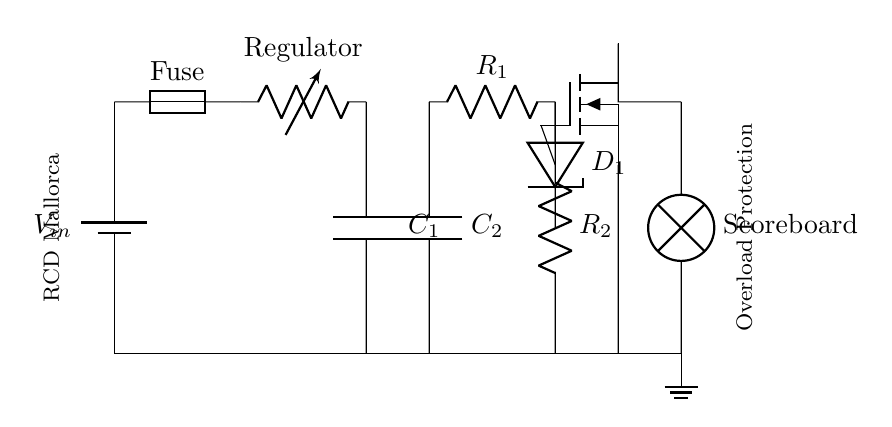What is the input component in this circuit? The input component is the battery, which supplies the voltage to the circuit. In the diagram, it is labeled as V_in.
Answer: battery What does the fuse protect in this circuit? The fuse protects the circuit from overload conditions by breaking the circuit if the current exceeds a certain threshold. This prevents damage to components like the scoreboard.
Answer: overload How many capacitors are used in the circuit? The circuit has two capacitors, labeled C1 and C2, which are used for filtering and stabilizing the voltage.
Answer: two What is the purpose of the MOSFET in this circuit? The MOSFET acts as a switch that controls the power to the scoreboard based on the signals it receives, thereby protecting against overloads.
Answer: switch What is the output load in this circuit? The output load is the scoreboard, which is represented as a lamp in the circuit. It receives power from the output side of the MOSFET.
Answer: scoreboard What role does the Zener diode play in this circuit? The Zener diode regulates voltage to ensure that it does not exceed a certain value, thus protecting sensitive components from voltage spikes.
Answer: voltage regulation What is the function of the voltage regulator? The voltage regulator maintains a constant output voltage level despite variations in input voltage or load conditions, ensuring stable operation for connected components.
Answer: voltage stability 